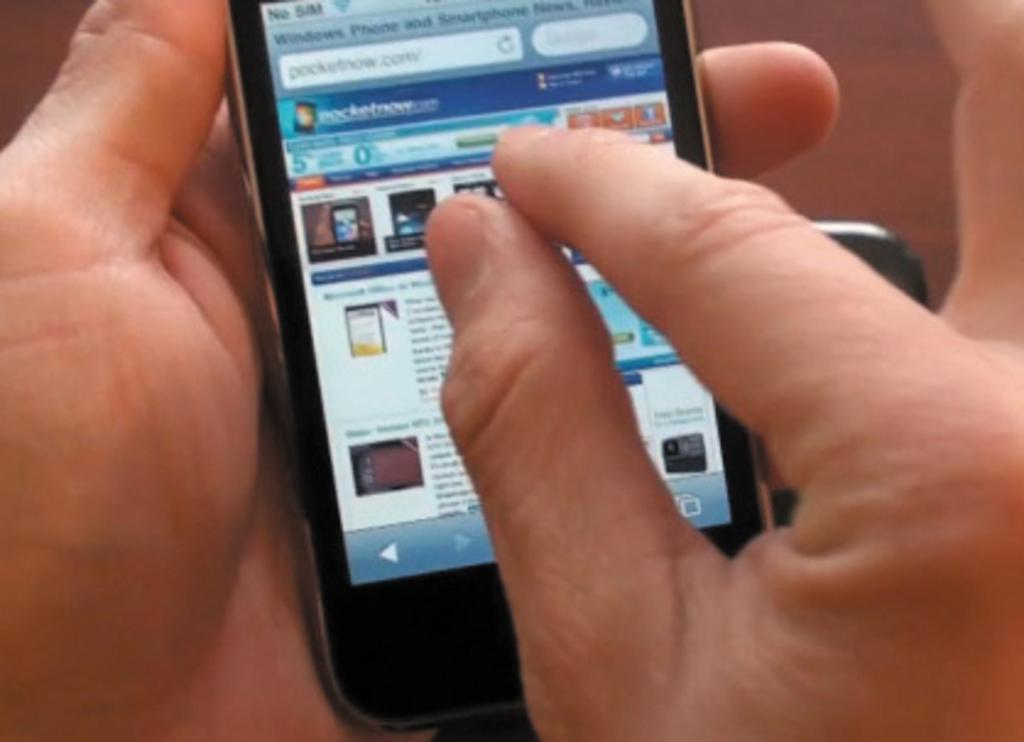Who is present in the image? There is a person in the image. What is the person holding in the image? The person is holding a cellphone. What can be seen on the cellphone screen? There is text visible on the cellphone screen. Is there smoke coming from the person's grandmother in the image? There is no grandmother or smoke present in the image. Can you see a stream in the background of the image? There is no stream visible in the image. 